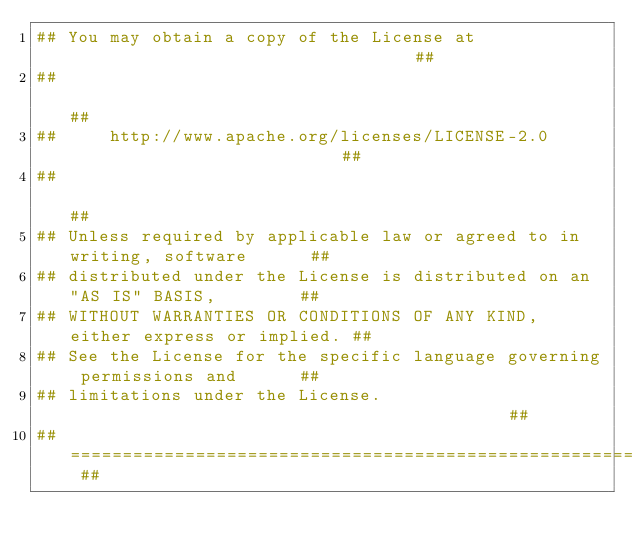<code> <loc_0><loc_0><loc_500><loc_500><_CMake_>## You may obtain a copy of the License at                                  ##
##                                                                          ##
##     http://www.apache.org/licenses/LICENSE-2.0                           ##
##                                                                          ##
## Unless required by applicable law or agreed to in writing, software      ##
## distributed under the License is distributed on an "AS IS" BASIS,        ##
## WITHOUT WARRANTIES OR CONDITIONS OF ANY KIND, either express or implied. ##
## See the License for the specific language governing permissions and      ##
## limitations under the License.                                           ##
## ======================================================================== ##
</code> 